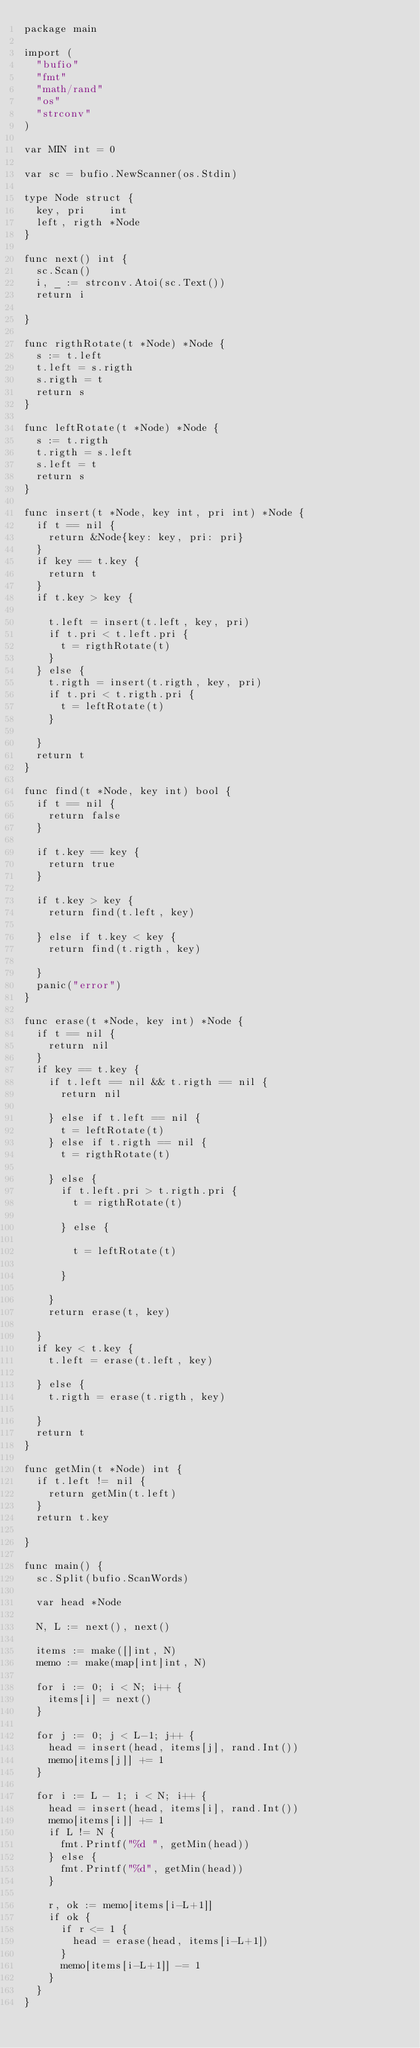Convert code to text. <code><loc_0><loc_0><loc_500><loc_500><_Go_>package main

import (
	"bufio"
	"fmt"
	"math/rand"
	"os"
	"strconv"
)

var MIN int = 0

var sc = bufio.NewScanner(os.Stdin)

type Node struct {
	key, pri    int
	left, rigth *Node
}

func next() int {
	sc.Scan()
	i, _ := strconv.Atoi(sc.Text())
	return i

}

func rigthRotate(t *Node) *Node {
	s := t.left
	t.left = s.rigth
	s.rigth = t
	return s
}

func leftRotate(t *Node) *Node {
	s := t.rigth
	t.rigth = s.left
	s.left = t
	return s
}

func insert(t *Node, key int, pri int) *Node {
	if t == nil {
		return &Node{key: key, pri: pri}
	}
	if key == t.key {
		return t
	}
	if t.key > key {

		t.left = insert(t.left, key, pri)
		if t.pri < t.left.pri {
			t = rigthRotate(t)
		}
	} else {
		t.rigth = insert(t.rigth, key, pri)
		if t.pri < t.rigth.pri {
			t = leftRotate(t)
		}

	}
	return t
}

func find(t *Node, key int) bool {
	if t == nil {
		return false
	}

	if t.key == key {
		return true
	}

	if t.key > key {
		return find(t.left, key)

	} else if t.key < key {
		return find(t.rigth, key)

	}
	panic("error")
}

func erase(t *Node, key int) *Node {
	if t == nil {
		return nil
	}
	if key == t.key {
		if t.left == nil && t.rigth == nil {
			return nil

		} else if t.left == nil {
			t = leftRotate(t)
		} else if t.rigth == nil {
			t = rigthRotate(t)

		} else {
			if t.left.pri > t.rigth.pri {
				t = rigthRotate(t)

			} else {

				t = leftRotate(t)

			}

		}
		return erase(t, key)

	}
	if key < t.key {
		t.left = erase(t.left, key)

	} else {
		t.rigth = erase(t.rigth, key)

	}
	return t
}

func getMin(t *Node) int {
	if t.left != nil {
		return getMin(t.left)
	}
	return t.key

}

func main() {
	sc.Split(bufio.ScanWords)

	var head *Node

	N, L := next(), next()

	items := make([]int, N)
	memo := make(map[int]int, N)

	for i := 0; i < N; i++ {
		items[i] = next()
	}

	for j := 0; j < L-1; j++ {
		head = insert(head, items[j], rand.Int())
		memo[items[j]] += 1
	}

	for i := L - 1; i < N; i++ {
		head = insert(head, items[i], rand.Int())
		memo[items[i]] += 1
		if L != N {
			fmt.Printf("%d ", getMin(head))
		} else {
			fmt.Printf("%d", getMin(head))
		}

		r, ok := memo[items[i-L+1]]
		if ok {
			if r <= 1 {
				head = erase(head, items[i-L+1])
			}
			memo[items[i-L+1]] -= 1
		}
	}
}

</code> 